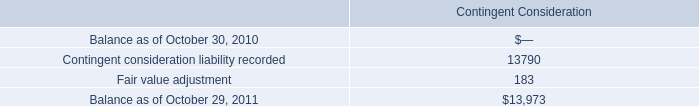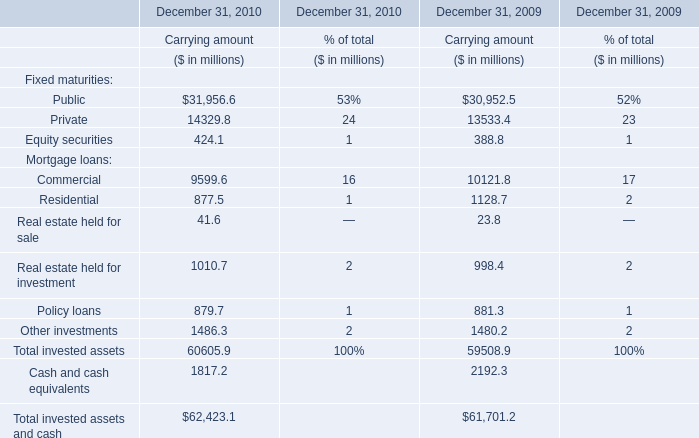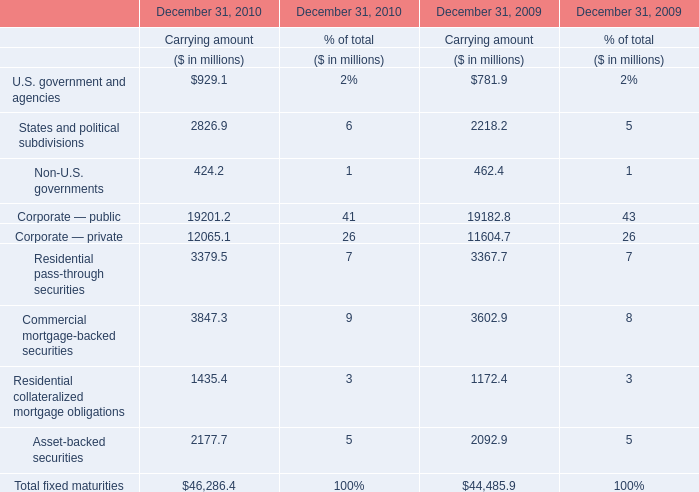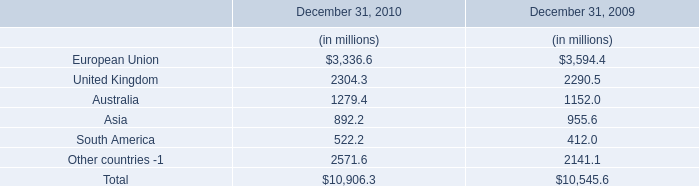what percentage of long-term debt was paid off from 2010 to 2011? 
Computations: ((416.3 - 413.4) / 416.3)
Answer: 0.00697. 